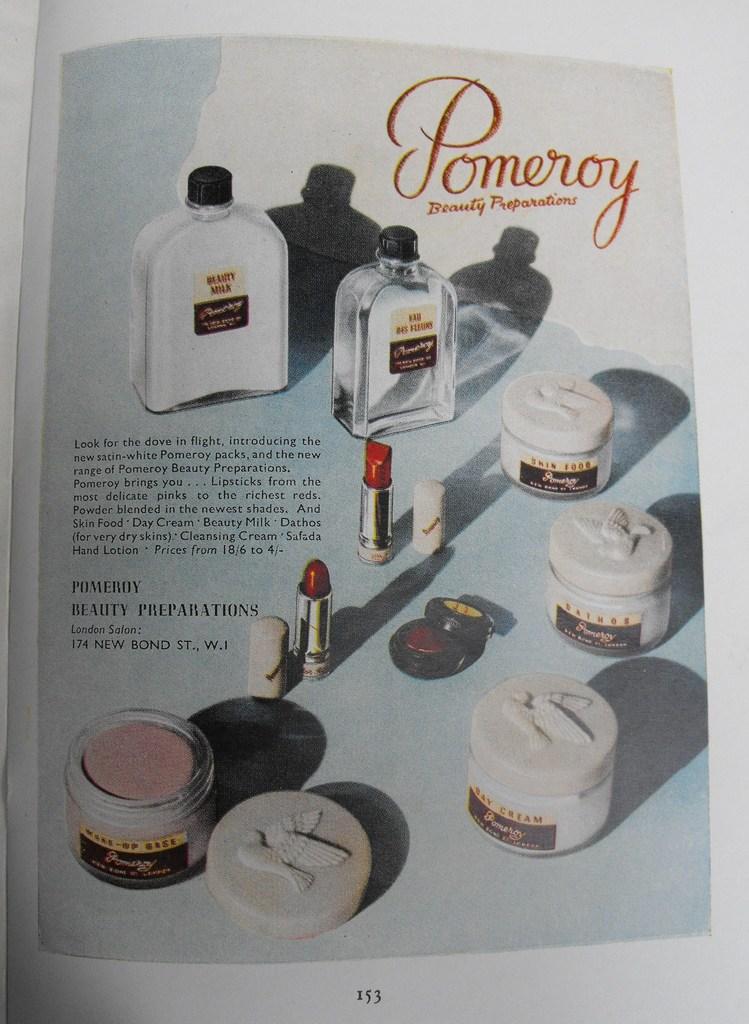What company is being advertised?
Ensure brevity in your answer.  Pomeroy. What page is this ad on?
Make the answer very short. 153. 